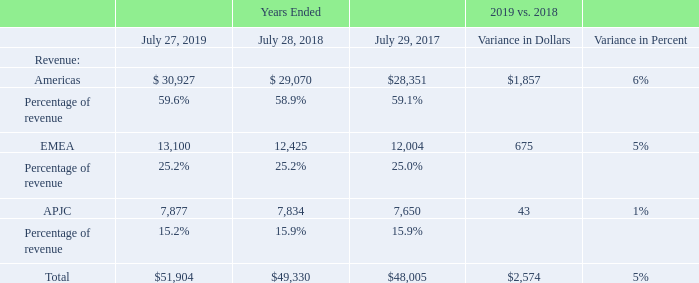Revenue
We manage our business on a geographic basis, organized into three geographic segments. Our revenue, which includes product and service for each segment, is summarized in the following table (in millions, except percentages):
Amounts may not sum and percentages may not recalculate due to rounding.
Total revenue in fiscal 2019 increased by 5% compared with fiscal 2018. Product revenue increased by 6% and service revenue increased by 2%. Our total revenue reflected growth across each of our geographic segments. Product revenue for the BRICM countries, in the aggregate, experienced 1% product revenue decline, driven by a 16% decrease in product revenue in China and a decrease of 1% in Brazil. These decreases were partially offset by increased product revenue in Mexico, Russia and India of 26%, 6% and 5%, respectively.
In addition to the impact of macroeconomic factors, including a reduced IT spending environment and reductions in spending by government entities, revenue by segment in a particular period may be significantly impacted by several factors related to revenue recognition, including the complexity of transactions such as multiple performance obligations; the mix of financing arrangements provided to channel partners and customers; and final acceptance of the product, system, or solution, among other factors. In addition, certain customers tend to make large and sporadic purchases, and the revenue related to these transactions may also be affected by the timing of revenue recognition, which in turn would impact the revenue of the relevant segment.
Which years does the table provide information about the company's revenue for each geographic segment? 2019, 2018, 2017. What was the revenue from Americas in 2019?
Answer scale should be: million. 30,927. What was the percentage of total revenue was from Americas in 2018?
Answer scale should be: percent. 58.9. What was the change for revenue from EMEA between 2017 and 2018?
Answer scale should be: million. 12,425-12,004
Answer: 421. How many years did total revenue from all segments exceed $50,000 million? 2019
Answer: 1. What was the percentage change in the revenue from APJC between 2018 and 2019?
Answer scale should be: percent. (7,877-7,834)/7,834
Answer: 0.55. 